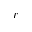Convert formula to latex. <formula><loc_0><loc_0><loc_500><loc_500>r</formula> 